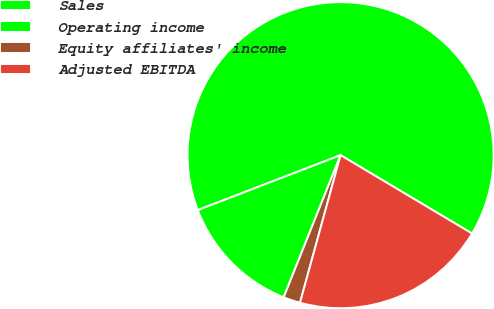<chart> <loc_0><loc_0><loc_500><loc_500><pie_chart><fcel>Sales<fcel>Operating income<fcel>Equity affiliates' income<fcel>Adjusted EBITDA<nl><fcel>64.4%<fcel>13.09%<fcel>1.79%<fcel>20.72%<nl></chart> 